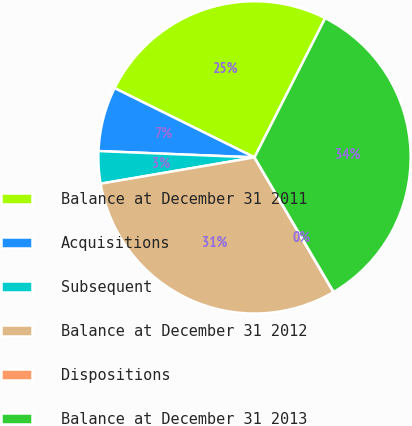<chart> <loc_0><loc_0><loc_500><loc_500><pie_chart><fcel>Balance at December 31 2011<fcel>Acquisitions<fcel>Subsequent<fcel>Balance at December 31 2012<fcel>Dispositions<fcel>Balance at December 31 2013<nl><fcel>25.16%<fcel>6.67%<fcel>3.34%<fcel>30.74%<fcel>0.02%<fcel>34.06%<nl></chart> 